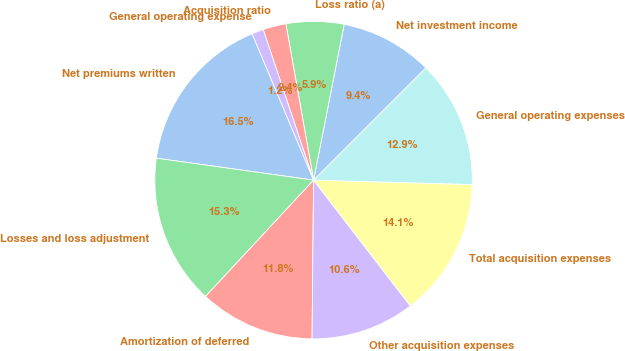<chart> <loc_0><loc_0><loc_500><loc_500><pie_chart><fcel>Net premiums written<fcel>Losses and loss adjustment<fcel>Amortization of deferred<fcel>Other acquisition expenses<fcel>Total acquisition expenses<fcel>General operating expenses<fcel>Net investment income<fcel>Loss ratio (a)<fcel>Acquisition ratio<fcel>General operating expense<nl><fcel>16.47%<fcel>15.29%<fcel>11.76%<fcel>10.59%<fcel>14.12%<fcel>12.94%<fcel>9.41%<fcel>5.88%<fcel>2.35%<fcel>1.18%<nl></chart> 